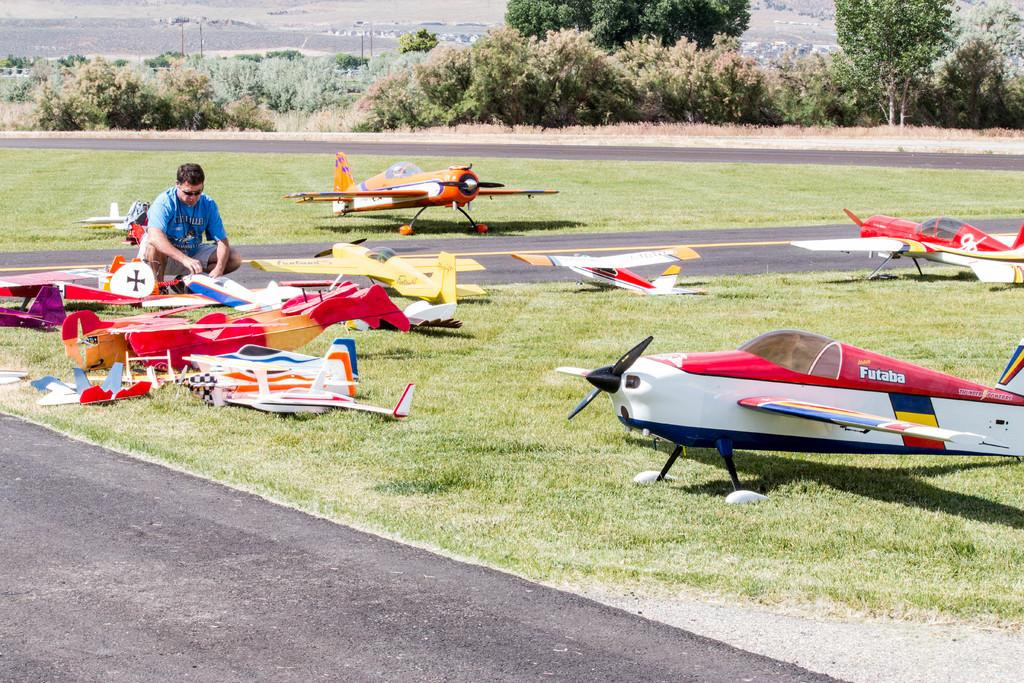<image>
Relay a brief, clear account of the picture shown. a very small aircraft with the word Futaba on it 